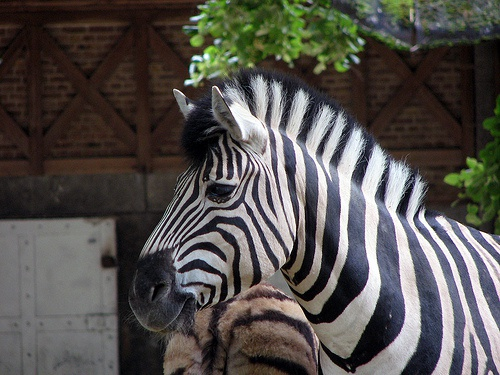Describe the objects in this image and their specific colors. I can see zebra in black, lightgray, gray, and darkgray tones and zebra in black, gray, and maroon tones in this image. 